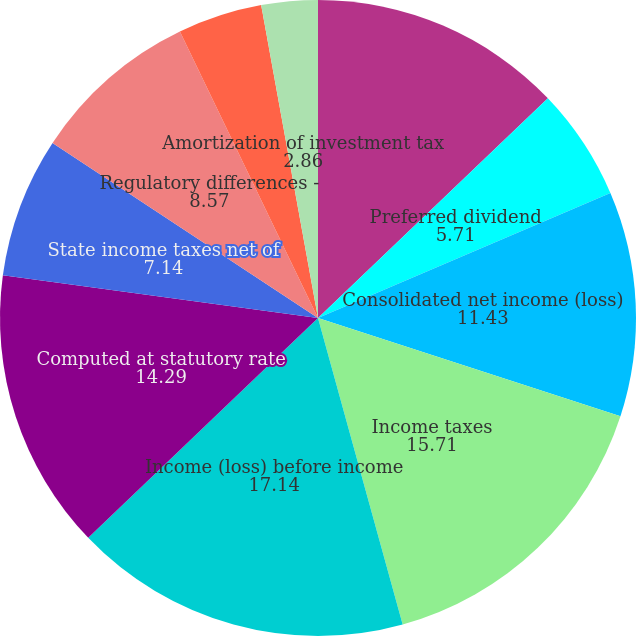<chart> <loc_0><loc_0><loc_500><loc_500><pie_chart><fcel>Net income (loss) attributable<fcel>Preferred dividend<fcel>Consolidated net income (loss)<fcel>Income taxes<fcel>Income (loss) before income<fcel>Computed at statutory rate<fcel>State income taxes net of<fcel>Regulatory differences -<fcel>Equity component of AFUDC<fcel>Amortization of investment tax<nl><fcel>12.86%<fcel>5.71%<fcel>11.43%<fcel>15.71%<fcel>17.14%<fcel>14.29%<fcel>7.14%<fcel>8.57%<fcel>4.29%<fcel>2.86%<nl></chart> 